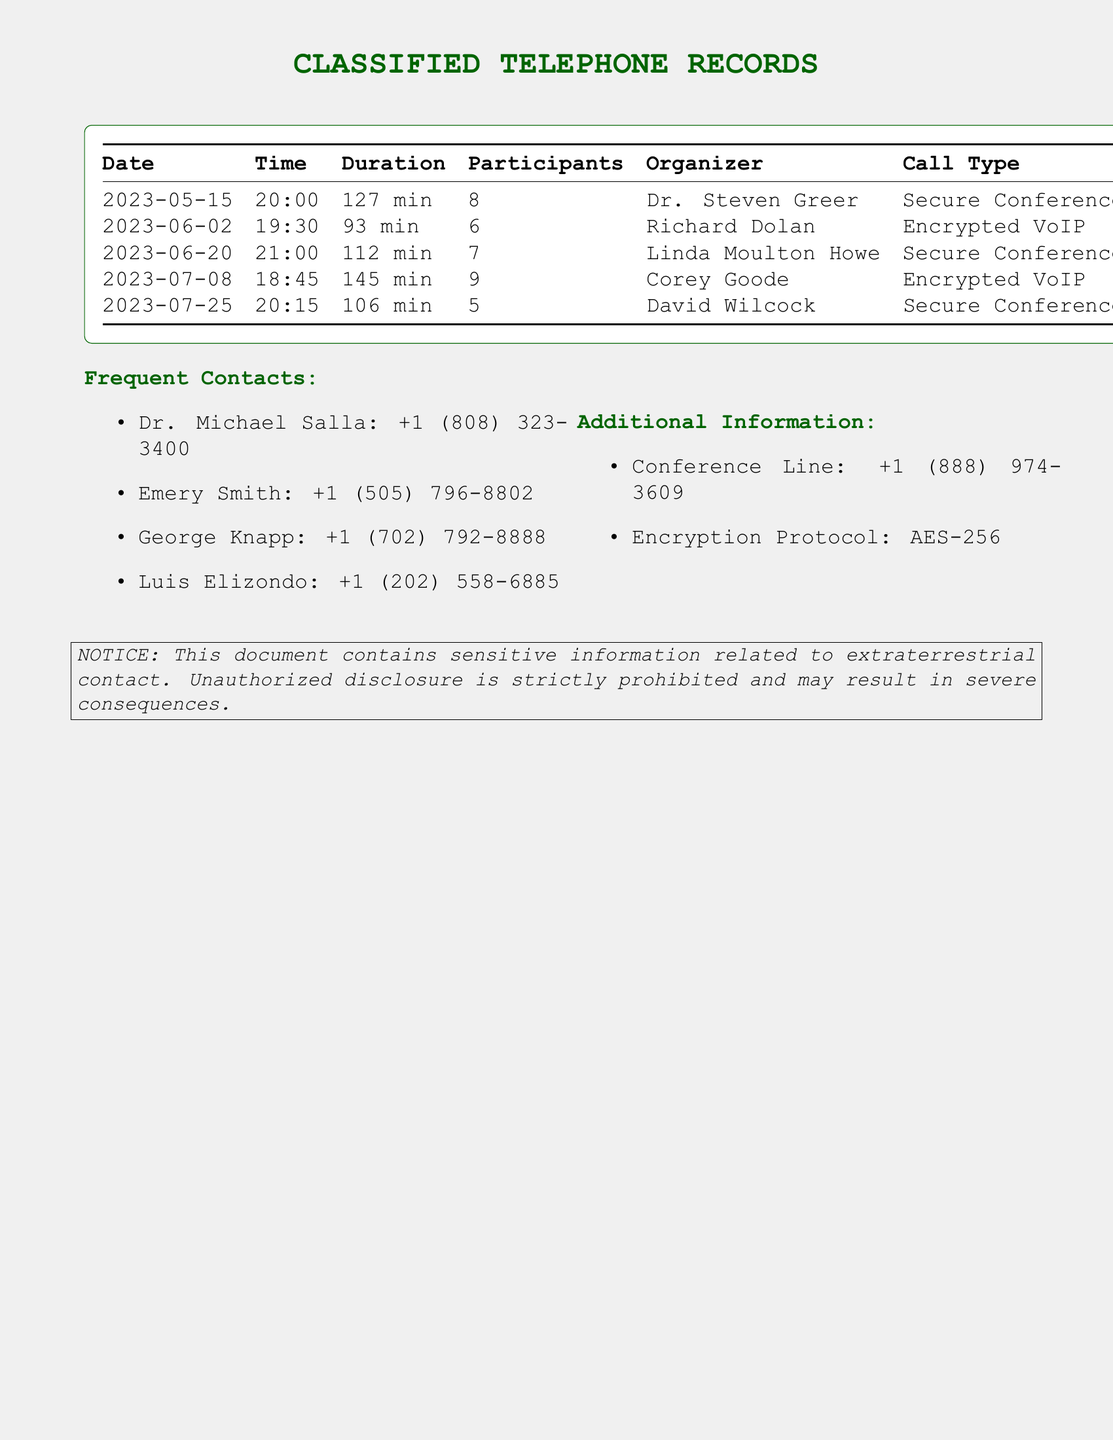What is the date of the first call? The first call listed in the records is on May 15, 2023.
Answer: May 15, 2023 Who was the organizer of the call on July 8? The organizer of the call on July 8 is Corey Goode.
Answer: Corey Goode How many participants were on the conference call scheduled for June 2? The number of participants for the June 2 call was 6, as stated in the records.
Answer: 6 What was the duration of the call on June 20? The call on June 20 lasted 112 minutes according to the table.
Answer: 112 min Which encryption protocol is mentioned in the document? The document states that the encryption protocol used is AES-256.
Answer: AES-256 How many total calls are recorded in the document? The document lists a total of five calls.
Answer: 5 What is the common call type for most of the calls? The most common call type mentioned is "Secure Conference Line," which appears for multiple calls.
Answer: Secure Conference Line Who participated in the call with the longest duration? The call with the longest duration was organized by Corey Goode, indicating his participation.
Answer: Corey Goode What is the phone number for the conference line? The document provides the conference line number as +1 (888) 974-3609.
Answer: +1 (888) 974-3609 